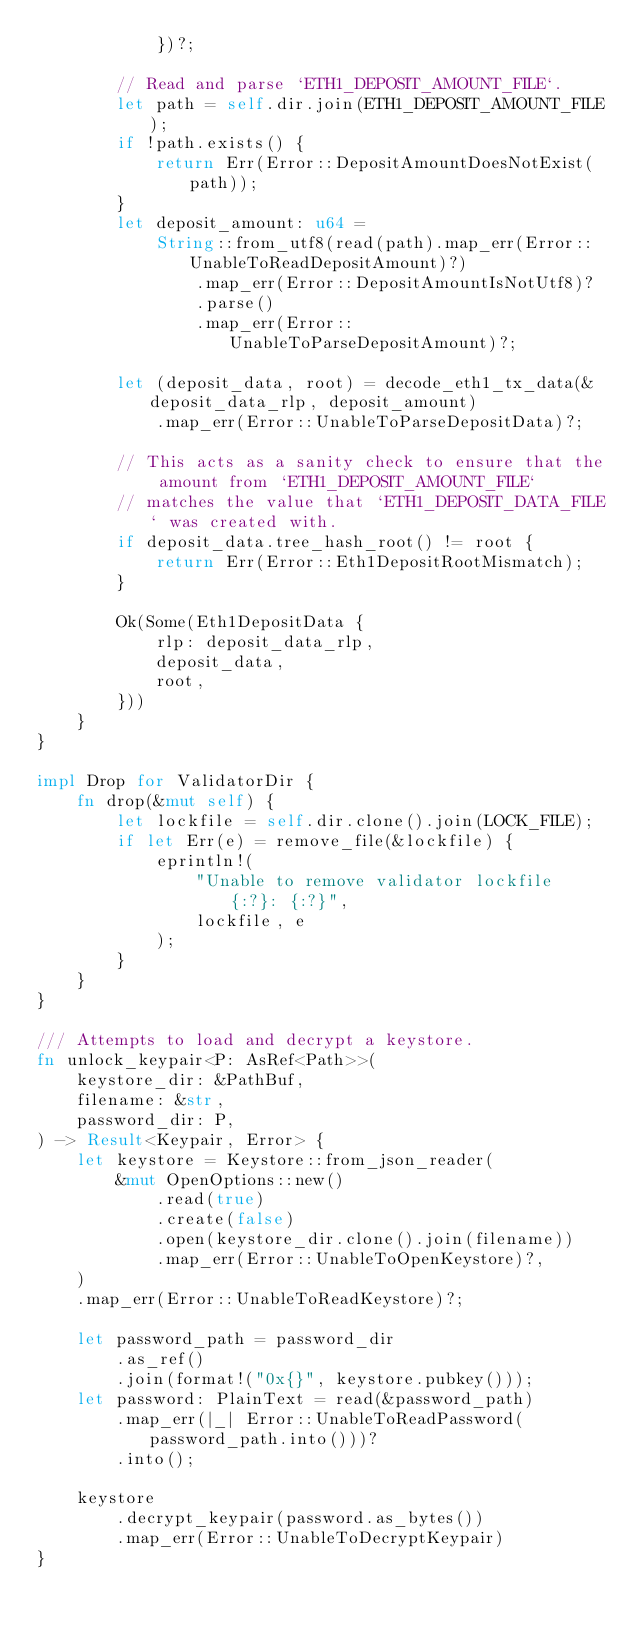Convert code to text. <code><loc_0><loc_0><loc_500><loc_500><_Rust_>            })?;

        // Read and parse `ETH1_DEPOSIT_AMOUNT_FILE`.
        let path = self.dir.join(ETH1_DEPOSIT_AMOUNT_FILE);
        if !path.exists() {
            return Err(Error::DepositAmountDoesNotExist(path));
        }
        let deposit_amount: u64 =
            String::from_utf8(read(path).map_err(Error::UnableToReadDepositAmount)?)
                .map_err(Error::DepositAmountIsNotUtf8)?
                .parse()
                .map_err(Error::UnableToParseDepositAmount)?;

        let (deposit_data, root) = decode_eth1_tx_data(&deposit_data_rlp, deposit_amount)
            .map_err(Error::UnableToParseDepositData)?;

        // This acts as a sanity check to ensure that the amount from `ETH1_DEPOSIT_AMOUNT_FILE`
        // matches the value that `ETH1_DEPOSIT_DATA_FILE` was created with.
        if deposit_data.tree_hash_root() != root {
            return Err(Error::Eth1DepositRootMismatch);
        }

        Ok(Some(Eth1DepositData {
            rlp: deposit_data_rlp,
            deposit_data,
            root,
        }))
    }
}

impl Drop for ValidatorDir {
    fn drop(&mut self) {
        let lockfile = self.dir.clone().join(LOCK_FILE);
        if let Err(e) = remove_file(&lockfile) {
            eprintln!(
                "Unable to remove validator lockfile {:?}: {:?}",
                lockfile, e
            );
        }
    }
}

/// Attempts to load and decrypt a keystore.
fn unlock_keypair<P: AsRef<Path>>(
    keystore_dir: &PathBuf,
    filename: &str,
    password_dir: P,
) -> Result<Keypair, Error> {
    let keystore = Keystore::from_json_reader(
        &mut OpenOptions::new()
            .read(true)
            .create(false)
            .open(keystore_dir.clone().join(filename))
            .map_err(Error::UnableToOpenKeystore)?,
    )
    .map_err(Error::UnableToReadKeystore)?;

    let password_path = password_dir
        .as_ref()
        .join(format!("0x{}", keystore.pubkey()));
    let password: PlainText = read(&password_path)
        .map_err(|_| Error::UnableToReadPassword(password_path.into()))?
        .into();

    keystore
        .decrypt_keypair(password.as_bytes())
        .map_err(Error::UnableToDecryptKeypair)
}
</code> 